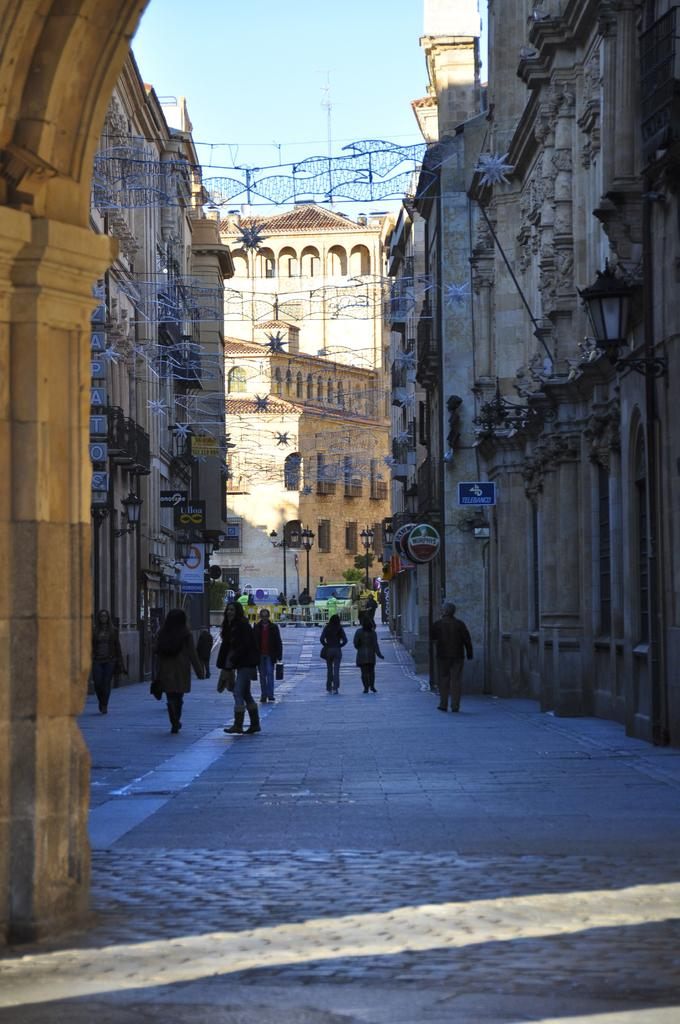What are the people in the image doing? The people in the image are on a path. What else can be seen in the image besides the people? There are buildings and street lights in the image. What is visible in the background of the image? The sky is visible in the background of the image. What type of treatment is the friend receiving from the parent in the image? There is no friend or parent present in the image, so it is not possible to answer that question. 